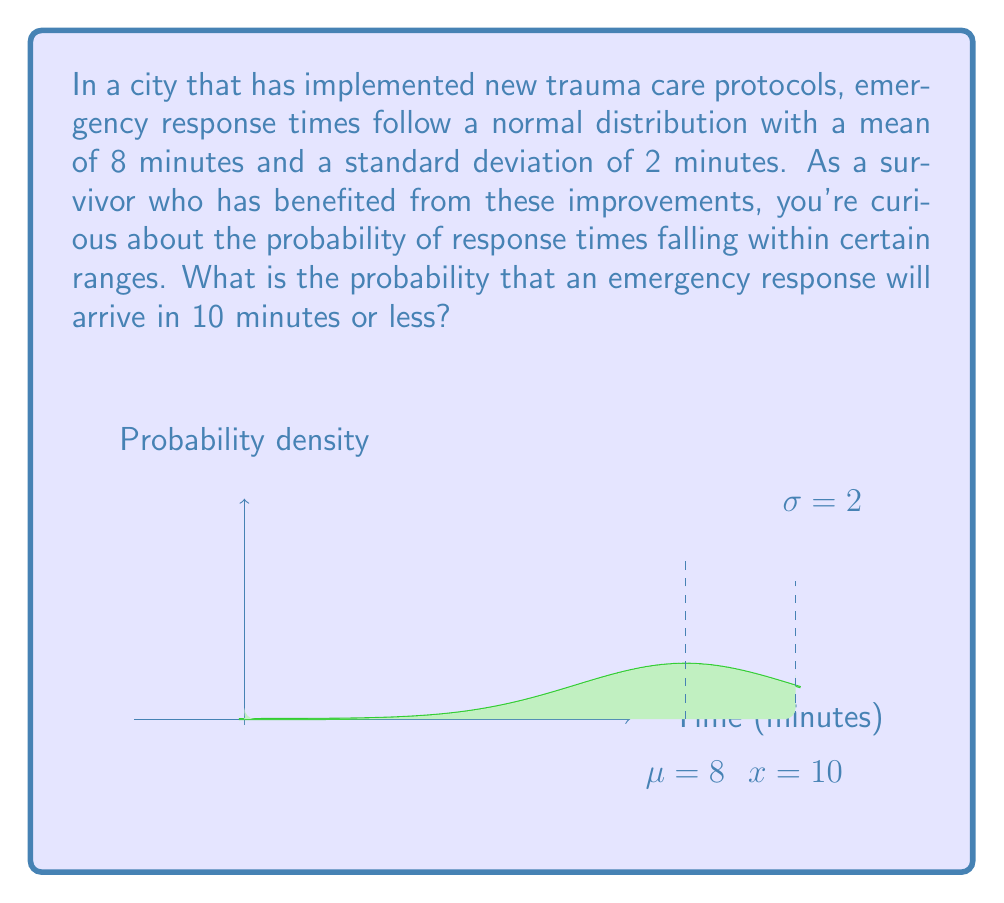Provide a solution to this math problem. Let's approach this step-by-step:

1) We're dealing with a normal distribution where:
   $\mu = 8$ minutes (mean)
   $\sigma = 2$ minutes (standard deviation)

2) We want to find $P(X \leq 10)$, where $X$ is the response time.

3) To solve this, we need to standardize the value and use the standard normal distribution (Z-score):

   $Z = \frac{X - \mu}{\sigma} = \frac{10 - 8}{2} = 1$

4) Now we need to find $P(Z \leq 1)$ using the standard normal table or a calculator.

5) Using a standard normal table or calculator, we find:

   $P(Z \leq 1) \approx 0.8413$

6) This means that approximately 84.13% of emergency responses will arrive in 10 minutes or less.

This improvement in response times, resulting from new trauma care protocols, significantly increases the chances of timely emergency assistance, which is crucial for trauma survivors.
Answer: $P(X \leq 10) \approx 0.8413$ or 84.13% 